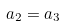<formula> <loc_0><loc_0><loc_500><loc_500>a _ { 2 } = a _ { 3 }</formula> 